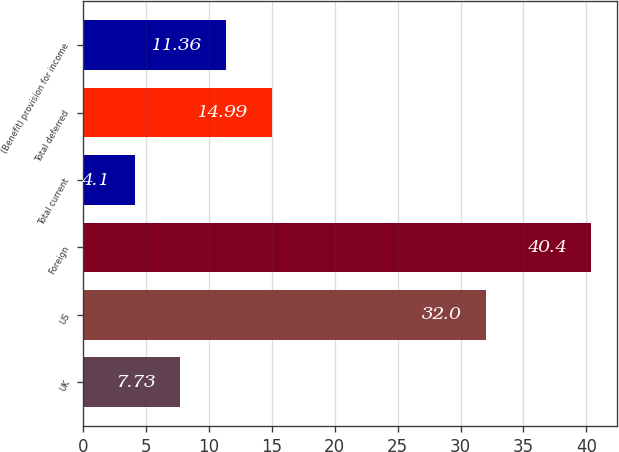Convert chart. <chart><loc_0><loc_0><loc_500><loc_500><bar_chart><fcel>UK<fcel>US<fcel>Foreign<fcel>Total current<fcel>Total deferred<fcel>(Benefit) provision for income<nl><fcel>7.73<fcel>32<fcel>40.4<fcel>4.1<fcel>14.99<fcel>11.36<nl></chart> 